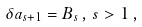Convert formula to latex. <formula><loc_0><loc_0><loc_500><loc_500>\delta a _ { s + 1 } = B _ { s } \, , \, s > 1 \, ,</formula> 